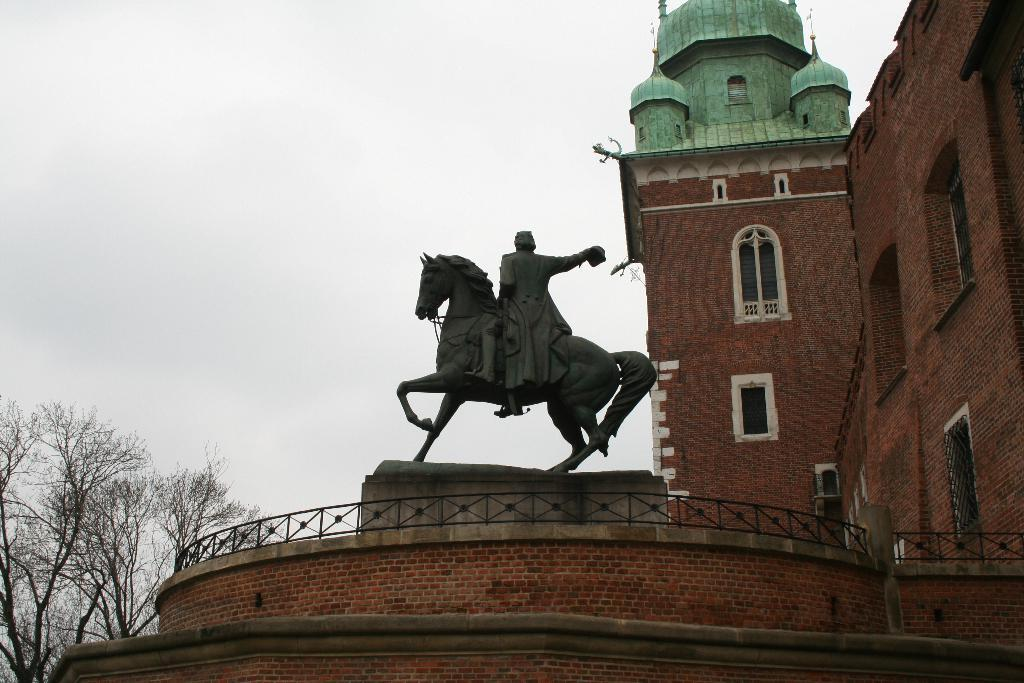What is the main subject of the image? There is a statue of a man sitting on a horse in the image. Where is the statue located in the image? The statue is in the middle of the image. What can be seen behind the statue on the right side? There is a building behind the statue on the right side. What is visible behind the statue on the left side? There are trees behind the statue on the left side. What is visible above the statue in the image? The sky is visible above the statue. How many apples are hanging from the horse's mane in the image? There are no apples present in the image, and therefore no apples can be seen hanging from the horse's mane. What causes the statue to burst into flames in the image? There is no indication in the image that the statue bursts into flames, and therefore no cause can be determined. 